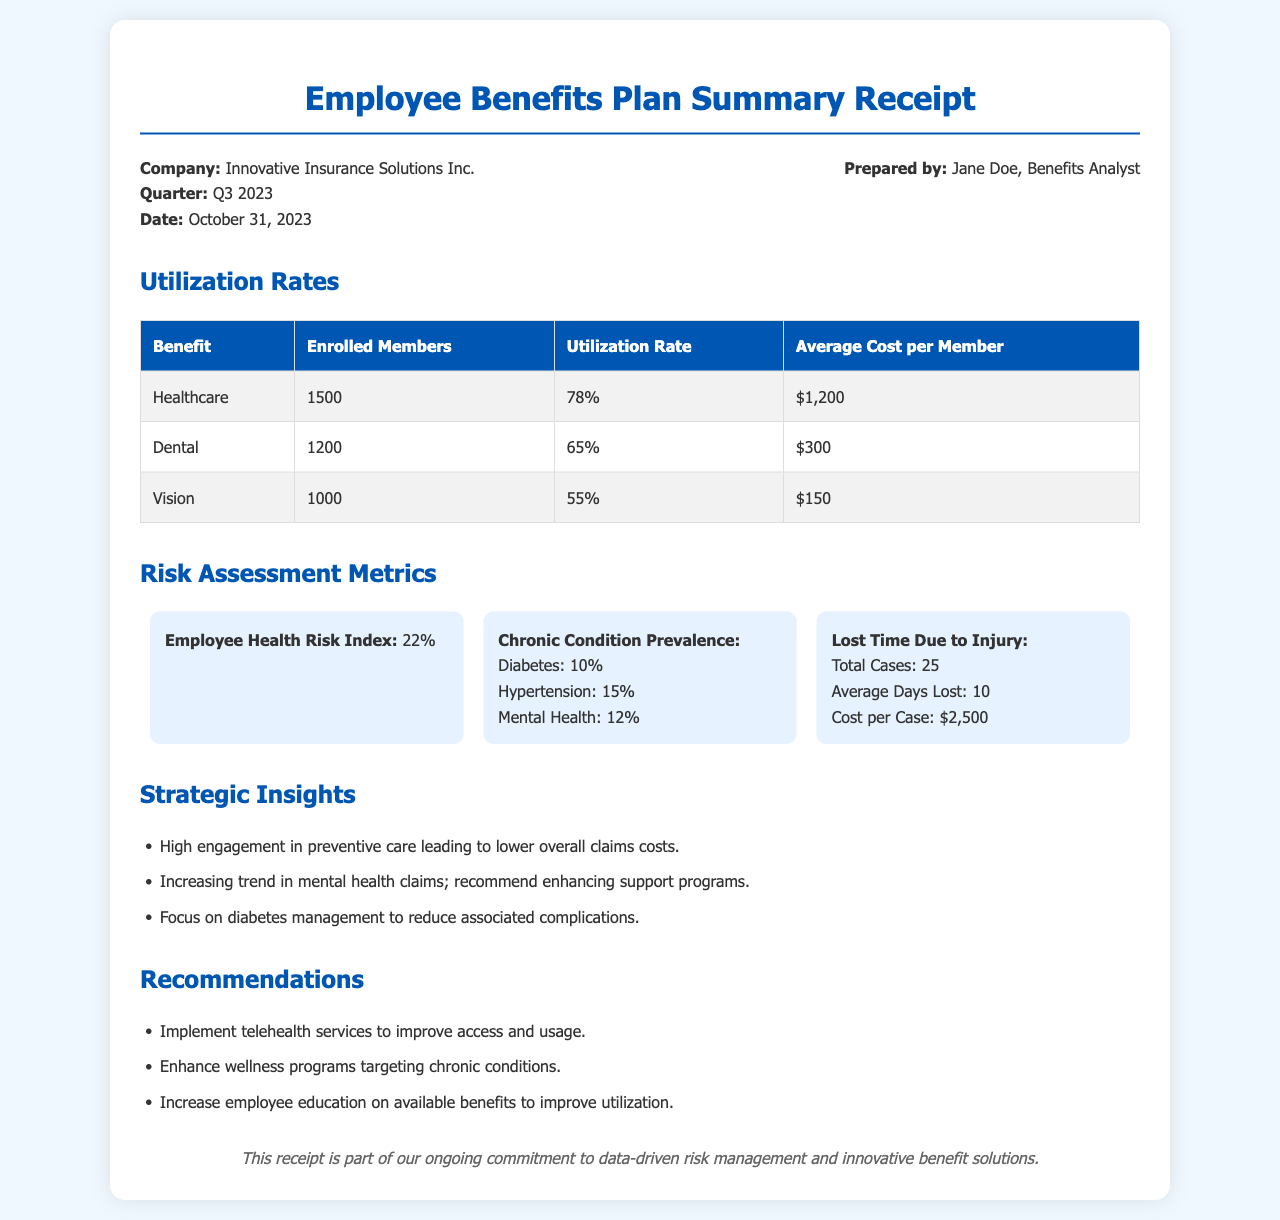what is the date of the report? The report is dated October 31, 2023, as indicated in the document.
Answer: October 31, 2023 who prepared the document? The document was prepared by Jane Doe, as mentioned in the header information.
Answer: Jane Doe what is the utilization rate for Dental benefits? The utilization rate for Dental benefits is highlighted in the utilization rates table.
Answer: 65% how many enrolled members are utilizing Healthcare benefits? The number of enrolled members for Healthcare benefits is provided in the utilization rates table.
Answer: 1500 what is the Employee Health Risk Index? The Employee Health Risk Index is a specific metric mentioned in the risk assessment metrics section.
Answer: 22% which chronic condition has the highest prevalence? The prevalence rates for chronic conditions are listed, with Hypertension being the highest.
Answer: Hypertension how many total cases were reported for Lost Time Due to Injury? The total cases reported for Lost Time Due to Injury is provided in the metrics section.
Answer: 25 what recommendation addresses chronic conditions? A specific recommendation in the document focuses on chronic conditions.
Answer: Enhance wellness programs targeting chronic conditions what strategic insight relates to mental health? The strategic insights include observations regarding mental health claims.
Answer: Increasing trend in mental health claims; recommend enhancing support programs 